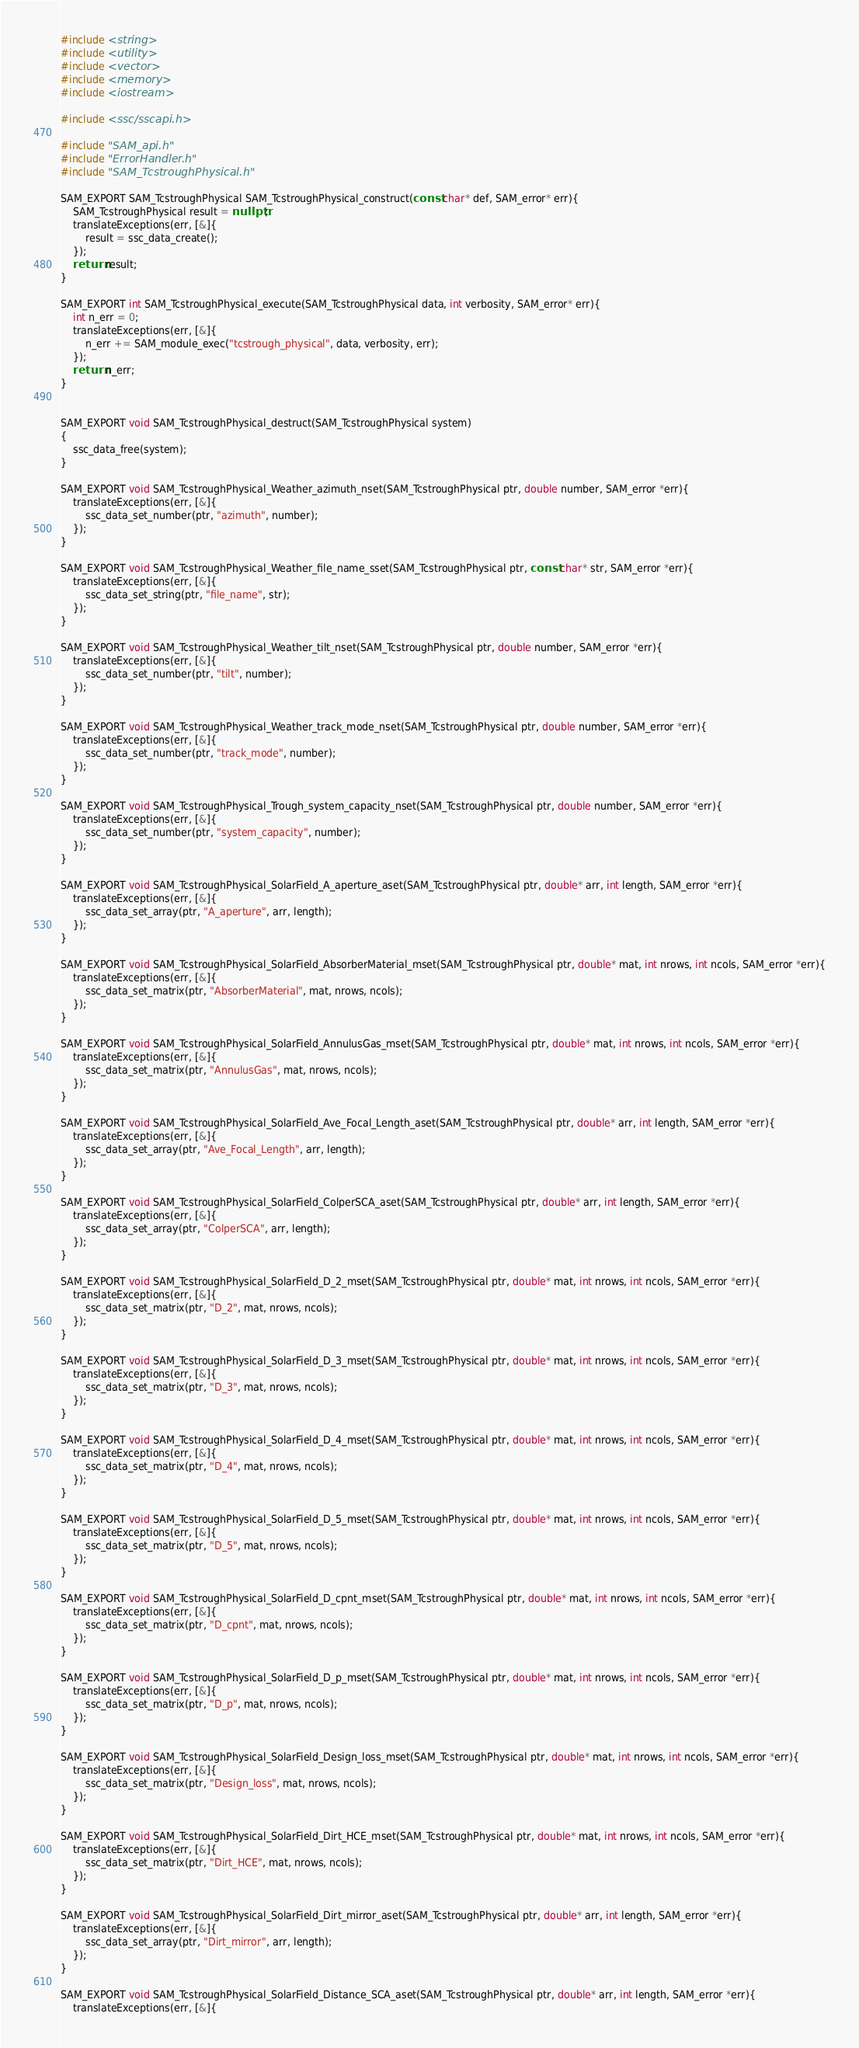<code> <loc_0><loc_0><loc_500><loc_500><_C++_>#include <string>
#include <utility>
#include <vector>
#include <memory>
#include <iostream>

#include <ssc/sscapi.h>

#include "SAM_api.h"
#include "ErrorHandler.h"
#include "SAM_TcstroughPhysical.h"

SAM_EXPORT SAM_TcstroughPhysical SAM_TcstroughPhysical_construct(const char* def, SAM_error* err){
	SAM_TcstroughPhysical result = nullptr;
	translateExceptions(err, [&]{
		result = ssc_data_create();
	});
	return result;
}

SAM_EXPORT int SAM_TcstroughPhysical_execute(SAM_TcstroughPhysical data, int verbosity, SAM_error* err){
	int n_err = 0;
	translateExceptions(err, [&]{
		n_err += SAM_module_exec("tcstrough_physical", data, verbosity, err);
	});
	return n_err;
}


SAM_EXPORT void SAM_TcstroughPhysical_destruct(SAM_TcstroughPhysical system)
{
	ssc_data_free(system);
}

SAM_EXPORT void SAM_TcstroughPhysical_Weather_azimuth_nset(SAM_TcstroughPhysical ptr, double number, SAM_error *err){
	translateExceptions(err, [&]{
		ssc_data_set_number(ptr, "azimuth", number);
	});
}

SAM_EXPORT void SAM_TcstroughPhysical_Weather_file_name_sset(SAM_TcstroughPhysical ptr, const char* str, SAM_error *err){
	translateExceptions(err, [&]{
		ssc_data_set_string(ptr, "file_name", str);
	});
}

SAM_EXPORT void SAM_TcstroughPhysical_Weather_tilt_nset(SAM_TcstroughPhysical ptr, double number, SAM_error *err){
	translateExceptions(err, [&]{
		ssc_data_set_number(ptr, "tilt", number);
	});
}

SAM_EXPORT void SAM_TcstroughPhysical_Weather_track_mode_nset(SAM_TcstroughPhysical ptr, double number, SAM_error *err){
	translateExceptions(err, [&]{
		ssc_data_set_number(ptr, "track_mode", number);
	});
}

SAM_EXPORT void SAM_TcstroughPhysical_Trough_system_capacity_nset(SAM_TcstroughPhysical ptr, double number, SAM_error *err){
	translateExceptions(err, [&]{
		ssc_data_set_number(ptr, "system_capacity", number);
	});
}

SAM_EXPORT void SAM_TcstroughPhysical_SolarField_A_aperture_aset(SAM_TcstroughPhysical ptr, double* arr, int length, SAM_error *err){
	translateExceptions(err, [&]{
		ssc_data_set_array(ptr, "A_aperture", arr, length);
	});
}

SAM_EXPORT void SAM_TcstroughPhysical_SolarField_AbsorberMaterial_mset(SAM_TcstroughPhysical ptr, double* mat, int nrows, int ncols, SAM_error *err){
	translateExceptions(err, [&]{
		ssc_data_set_matrix(ptr, "AbsorberMaterial", mat, nrows, ncols);
	});
}

SAM_EXPORT void SAM_TcstroughPhysical_SolarField_AnnulusGas_mset(SAM_TcstroughPhysical ptr, double* mat, int nrows, int ncols, SAM_error *err){
	translateExceptions(err, [&]{
		ssc_data_set_matrix(ptr, "AnnulusGas", mat, nrows, ncols);
	});
}

SAM_EXPORT void SAM_TcstroughPhysical_SolarField_Ave_Focal_Length_aset(SAM_TcstroughPhysical ptr, double* arr, int length, SAM_error *err){
	translateExceptions(err, [&]{
		ssc_data_set_array(ptr, "Ave_Focal_Length", arr, length);
	});
}

SAM_EXPORT void SAM_TcstroughPhysical_SolarField_ColperSCA_aset(SAM_TcstroughPhysical ptr, double* arr, int length, SAM_error *err){
	translateExceptions(err, [&]{
		ssc_data_set_array(ptr, "ColperSCA", arr, length);
	});
}

SAM_EXPORT void SAM_TcstroughPhysical_SolarField_D_2_mset(SAM_TcstroughPhysical ptr, double* mat, int nrows, int ncols, SAM_error *err){
	translateExceptions(err, [&]{
		ssc_data_set_matrix(ptr, "D_2", mat, nrows, ncols);
	});
}

SAM_EXPORT void SAM_TcstroughPhysical_SolarField_D_3_mset(SAM_TcstroughPhysical ptr, double* mat, int nrows, int ncols, SAM_error *err){
	translateExceptions(err, [&]{
		ssc_data_set_matrix(ptr, "D_3", mat, nrows, ncols);
	});
}

SAM_EXPORT void SAM_TcstroughPhysical_SolarField_D_4_mset(SAM_TcstroughPhysical ptr, double* mat, int nrows, int ncols, SAM_error *err){
	translateExceptions(err, [&]{
		ssc_data_set_matrix(ptr, "D_4", mat, nrows, ncols);
	});
}

SAM_EXPORT void SAM_TcstroughPhysical_SolarField_D_5_mset(SAM_TcstroughPhysical ptr, double* mat, int nrows, int ncols, SAM_error *err){
	translateExceptions(err, [&]{
		ssc_data_set_matrix(ptr, "D_5", mat, nrows, ncols);
	});
}

SAM_EXPORT void SAM_TcstroughPhysical_SolarField_D_cpnt_mset(SAM_TcstroughPhysical ptr, double* mat, int nrows, int ncols, SAM_error *err){
	translateExceptions(err, [&]{
		ssc_data_set_matrix(ptr, "D_cpnt", mat, nrows, ncols);
	});
}

SAM_EXPORT void SAM_TcstroughPhysical_SolarField_D_p_mset(SAM_TcstroughPhysical ptr, double* mat, int nrows, int ncols, SAM_error *err){
	translateExceptions(err, [&]{
		ssc_data_set_matrix(ptr, "D_p", mat, nrows, ncols);
	});
}

SAM_EXPORT void SAM_TcstroughPhysical_SolarField_Design_loss_mset(SAM_TcstroughPhysical ptr, double* mat, int nrows, int ncols, SAM_error *err){
	translateExceptions(err, [&]{
		ssc_data_set_matrix(ptr, "Design_loss", mat, nrows, ncols);
	});
}

SAM_EXPORT void SAM_TcstroughPhysical_SolarField_Dirt_HCE_mset(SAM_TcstroughPhysical ptr, double* mat, int nrows, int ncols, SAM_error *err){
	translateExceptions(err, [&]{
		ssc_data_set_matrix(ptr, "Dirt_HCE", mat, nrows, ncols);
	});
}

SAM_EXPORT void SAM_TcstroughPhysical_SolarField_Dirt_mirror_aset(SAM_TcstroughPhysical ptr, double* arr, int length, SAM_error *err){
	translateExceptions(err, [&]{
		ssc_data_set_array(ptr, "Dirt_mirror", arr, length);
	});
}

SAM_EXPORT void SAM_TcstroughPhysical_SolarField_Distance_SCA_aset(SAM_TcstroughPhysical ptr, double* arr, int length, SAM_error *err){
	translateExceptions(err, [&]{</code> 